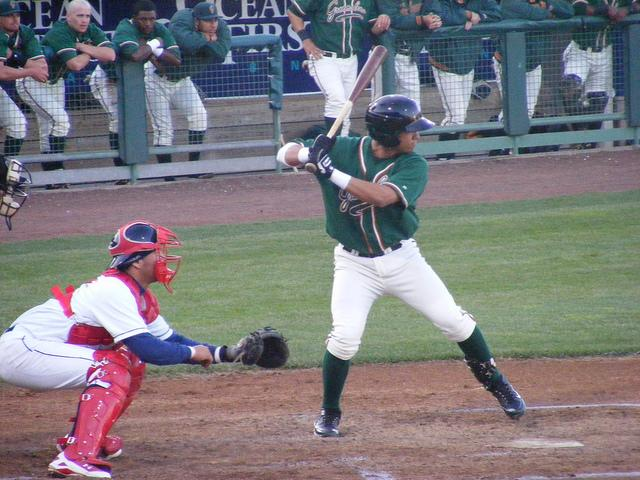What is going to approach the two men in front soon? Please explain your reasoning. baseball. The men are playing baseball and are waiting on the ball. 